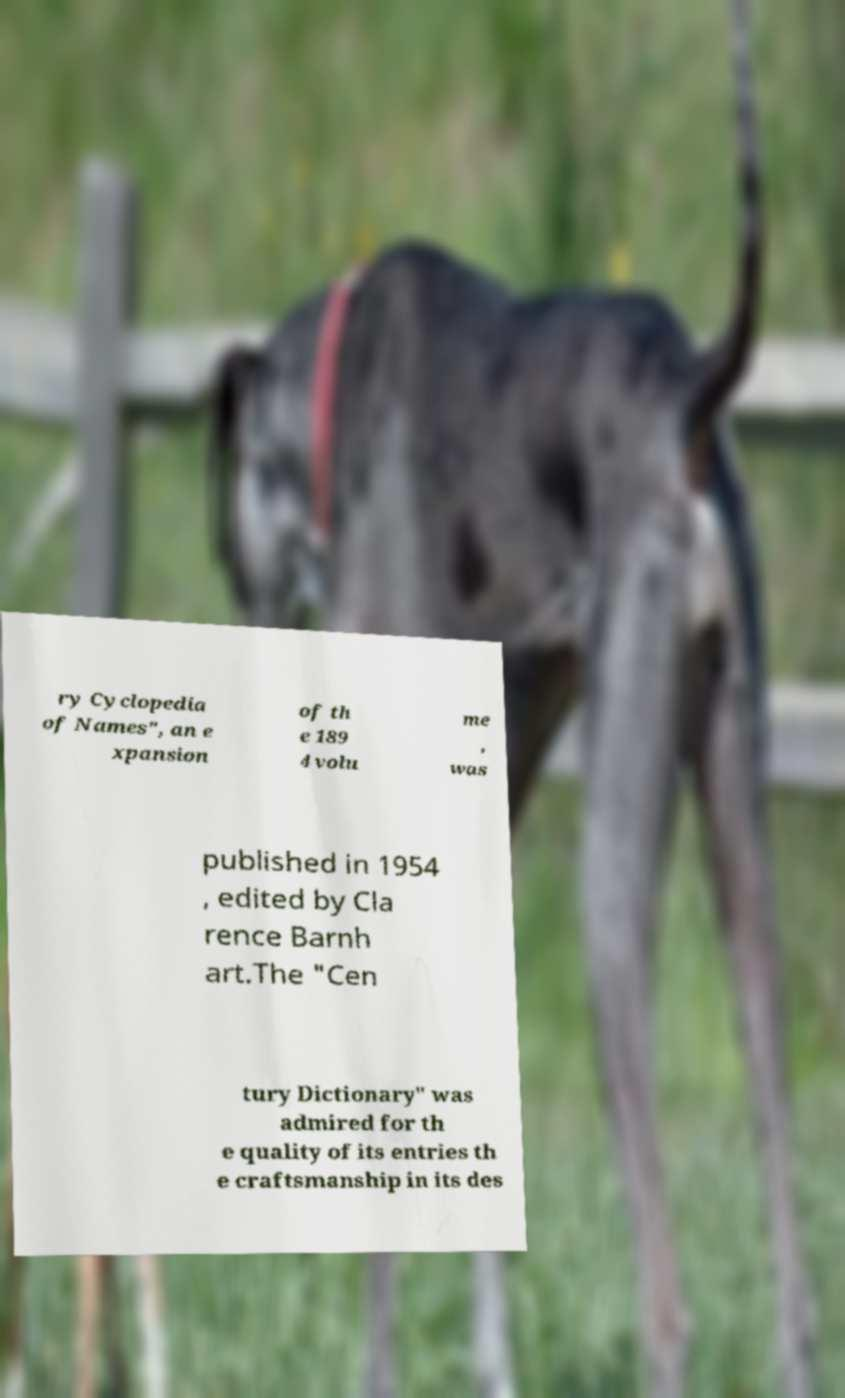What messages or text are displayed in this image? I need them in a readable, typed format. ry Cyclopedia of Names", an e xpansion of th e 189 4 volu me , was published in 1954 , edited by Cla rence Barnh art.The "Cen tury Dictionary" was admired for th e quality of its entries th e craftsmanship in its des 